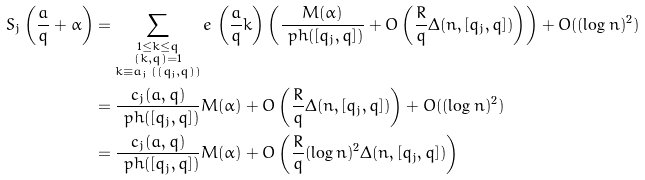<formula> <loc_0><loc_0><loc_500><loc_500>S _ { j } \left ( \frac { a } { q } + \alpha \right ) & = \sum _ { \substack { 1 \leq k \leq q \\ ( k , q ) = 1 \\ k \equiv a _ { j } \, ( ( q _ { j } , q ) ) } } e \, \left ( \frac { a } { q } k \right ) \left ( \frac { M ( \alpha ) } { \ p h ( [ q _ { j } , q ] ) } + O \left ( \frac { R } { q } \Delta ( n , [ q _ { j } , q ] ) \right ) \right ) + O ( ( \log n ) ^ { 2 } ) \\ & = \frac { c _ { j } ( a , q ) } { \ p h ( [ q _ { j } , q ] ) } M ( \alpha ) + O \left ( \frac { R } { q } \Delta ( n , [ q _ { j } , q ] ) \right ) + O ( ( \log n ) ^ { 2 } ) \\ & = \frac { c _ { j } ( a , q ) } { \ p h ( [ q _ { j } , q ] ) } M ( \alpha ) + O \left ( \frac { R } { q } ( \log n ) ^ { 2 } \Delta ( n , [ q _ { j } , q ] ) \right )</formula> 